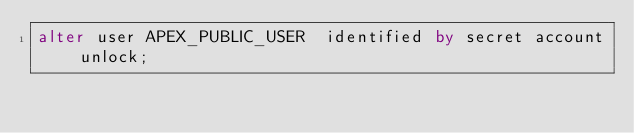Convert code to text. <code><loc_0><loc_0><loc_500><loc_500><_SQL_>alter user APEX_PUBLIC_USER  identified by secret account unlock;
</code> 